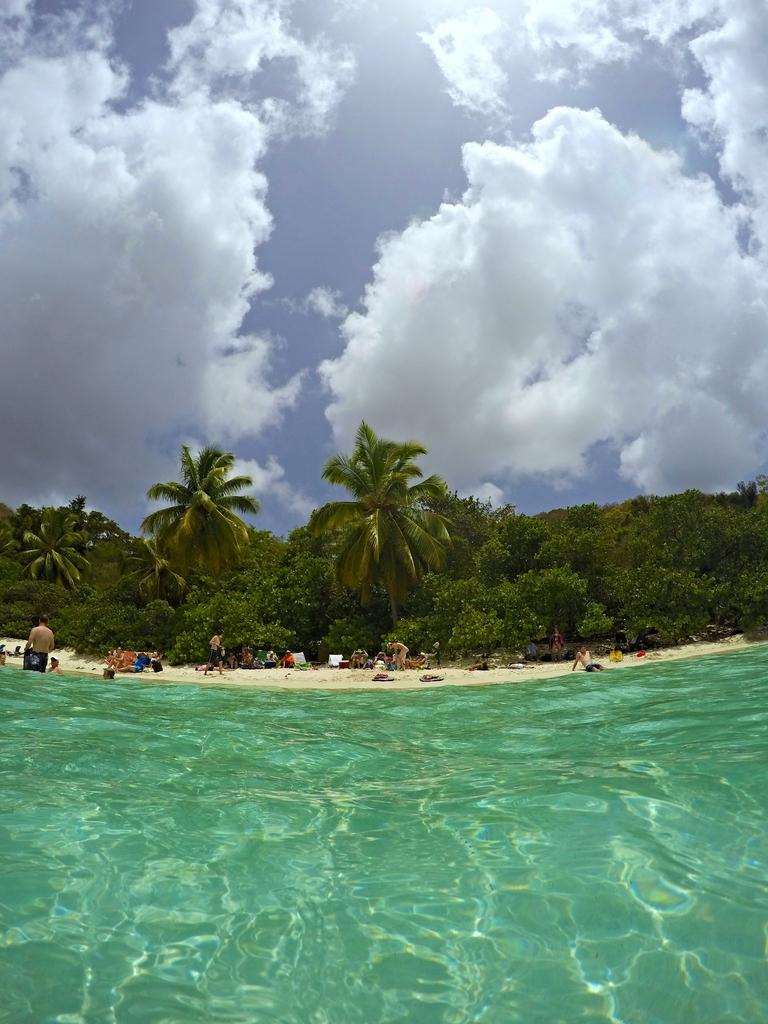What is the primary element visible in the image? There is water in the image. What can be seen in the background of the image? There are people, trees, and the sky visible in the background of the image. What is the condition of the sky in the image? Clouds are present in the sky. What type of bell can be heard ringing in the image? There is no bell present in the image, and therefore no sound can be heard. 